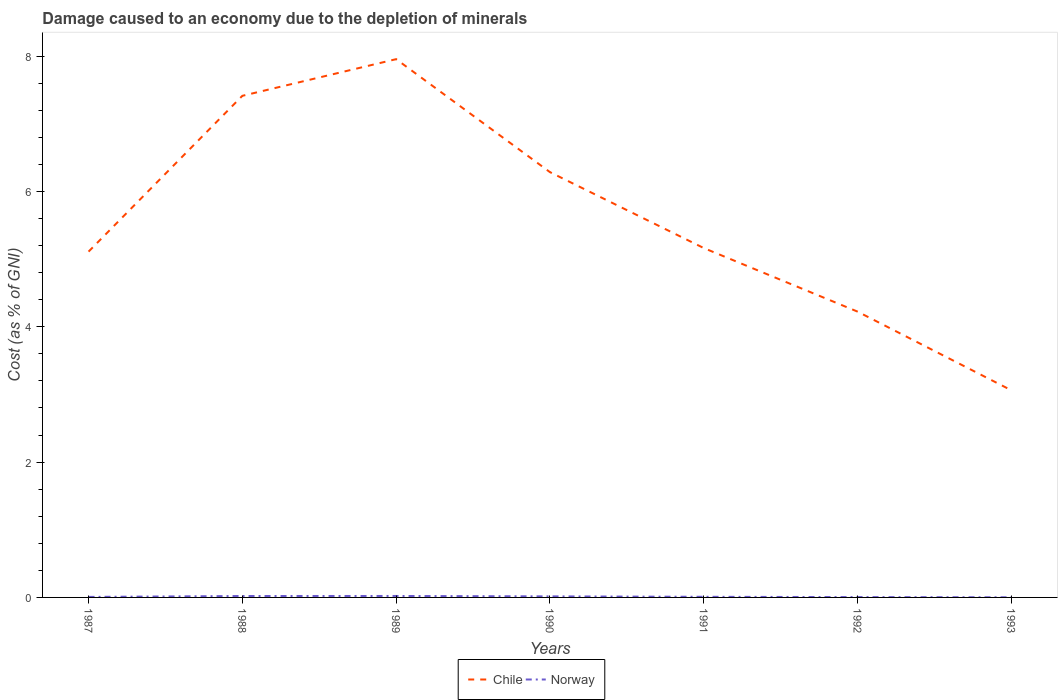Does the line corresponding to Norway intersect with the line corresponding to Chile?
Your answer should be very brief. No. Is the number of lines equal to the number of legend labels?
Your response must be concise. Yes. Across all years, what is the maximum cost of damage caused due to the depletion of minerals in Chile?
Give a very brief answer. 3.06. In which year was the cost of damage caused due to the depletion of minerals in Chile maximum?
Provide a short and direct response. 1993. What is the total cost of damage caused due to the depletion of minerals in Norway in the graph?
Provide a succinct answer. 0.01. What is the difference between the highest and the second highest cost of damage caused due to the depletion of minerals in Norway?
Provide a short and direct response. 0.02. Is the cost of damage caused due to the depletion of minerals in Chile strictly greater than the cost of damage caused due to the depletion of minerals in Norway over the years?
Provide a short and direct response. No. How many lines are there?
Provide a short and direct response. 2. Are the values on the major ticks of Y-axis written in scientific E-notation?
Your answer should be very brief. No. Does the graph contain any zero values?
Offer a terse response. No. Does the graph contain grids?
Your answer should be very brief. No. What is the title of the graph?
Your answer should be compact. Damage caused to an economy due to the depletion of minerals. What is the label or title of the Y-axis?
Keep it short and to the point. Cost (as % of GNI). What is the Cost (as % of GNI) in Chile in 1987?
Offer a terse response. 5.11. What is the Cost (as % of GNI) in Norway in 1987?
Offer a very short reply. 0.01. What is the Cost (as % of GNI) of Chile in 1988?
Your answer should be compact. 7.41. What is the Cost (as % of GNI) in Norway in 1988?
Ensure brevity in your answer.  0.02. What is the Cost (as % of GNI) in Chile in 1989?
Offer a terse response. 7.96. What is the Cost (as % of GNI) in Norway in 1989?
Provide a short and direct response. 0.02. What is the Cost (as % of GNI) of Chile in 1990?
Offer a terse response. 6.29. What is the Cost (as % of GNI) of Norway in 1990?
Provide a succinct answer. 0.02. What is the Cost (as % of GNI) of Chile in 1991?
Provide a succinct answer. 5.16. What is the Cost (as % of GNI) of Norway in 1991?
Provide a succinct answer. 0.01. What is the Cost (as % of GNI) of Chile in 1992?
Provide a short and direct response. 4.22. What is the Cost (as % of GNI) of Norway in 1992?
Make the answer very short. 0.01. What is the Cost (as % of GNI) in Chile in 1993?
Provide a succinct answer. 3.06. What is the Cost (as % of GNI) in Norway in 1993?
Ensure brevity in your answer.  0. Across all years, what is the maximum Cost (as % of GNI) of Chile?
Provide a short and direct response. 7.96. Across all years, what is the maximum Cost (as % of GNI) in Norway?
Offer a terse response. 0.02. Across all years, what is the minimum Cost (as % of GNI) in Chile?
Your answer should be very brief. 3.06. Across all years, what is the minimum Cost (as % of GNI) in Norway?
Provide a short and direct response. 0. What is the total Cost (as % of GNI) of Chile in the graph?
Make the answer very short. 39.22. What is the total Cost (as % of GNI) of Norway in the graph?
Offer a terse response. 0.08. What is the difference between the Cost (as % of GNI) in Chile in 1987 and that in 1988?
Keep it short and to the point. -2.3. What is the difference between the Cost (as % of GNI) of Norway in 1987 and that in 1988?
Make the answer very short. -0.01. What is the difference between the Cost (as % of GNI) of Chile in 1987 and that in 1989?
Your response must be concise. -2.84. What is the difference between the Cost (as % of GNI) in Norway in 1987 and that in 1989?
Your answer should be compact. -0.01. What is the difference between the Cost (as % of GNI) of Chile in 1987 and that in 1990?
Provide a short and direct response. -1.17. What is the difference between the Cost (as % of GNI) of Norway in 1987 and that in 1990?
Give a very brief answer. -0.01. What is the difference between the Cost (as % of GNI) in Chile in 1987 and that in 1991?
Make the answer very short. -0.05. What is the difference between the Cost (as % of GNI) of Norway in 1987 and that in 1991?
Your answer should be very brief. -0. What is the difference between the Cost (as % of GNI) of Chile in 1987 and that in 1992?
Provide a short and direct response. 0.89. What is the difference between the Cost (as % of GNI) of Norway in 1987 and that in 1992?
Give a very brief answer. 0. What is the difference between the Cost (as % of GNI) of Chile in 1987 and that in 1993?
Your response must be concise. 2.05. What is the difference between the Cost (as % of GNI) of Norway in 1987 and that in 1993?
Offer a terse response. 0.01. What is the difference between the Cost (as % of GNI) of Chile in 1988 and that in 1989?
Provide a short and direct response. -0.54. What is the difference between the Cost (as % of GNI) of Norway in 1988 and that in 1989?
Offer a very short reply. -0. What is the difference between the Cost (as % of GNI) in Chile in 1988 and that in 1990?
Give a very brief answer. 1.13. What is the difference between the Cost (as % of GNI) of Norway in 1988 and that in 1990?
Make the answer very short. 0.01. What is the difference between the Cost (as % of GNI) in Chile in 1988 and that in 1991?
Give a very brief answer. 2.25. What is the difference between the Cost (as % of GNI) of Norway in 1988 and that in 1991?
Provide a short and direct response. 0.01. What is the difference between the Cost (as % of GNI) in Chile in 1988 and that in 1992?
Provide a succinct answer. 3.19. What is the difference between the Cost (as % of GNI) in Norway in 1988 and that in 1992?
Provide a short and direct response. 0.02. What is the difference between the Cost (as % of GNI) in Chile in 1988 and that in 1993?
Your answer should be compact. 4.35. What is the difference between the Cost (as % of GNI) of Norway in 1988 and that in 1993?
Offer a terse response. 0.02. What is the difference between the Cost (as % of GNI) in Chile in 1989 and that in 1990?
Offer a very short reply. 1.67. What is the difference between the Cost (as % of GNI) of Norway in 1989 and that in 1990?
Offer a terse response. 0.01. What is the difference between the Cost (as % of GNI) of Chile in 1989 and that in 1991?
Make the answer very short. 2.79. What is the difference between the Cost (as % of GNI) of Norway in 1989 and that in 1991?
Your response must be concise. 0.01. What is the difference between the Cost (as % of GNI) of Chile in 1989 and that in 1992?
Your answer should be compact. 3.73. What is the difference between the Cost (as % of GNI) in Norway in 1989 and that in 1992?
Your response must be concise. 0.02. What is the difference between the Cost (as % of GNI) of Chile in 1989 and that in 1993?
Keep it short and to the point. 4.89. What is the difference between the Cost (as % of GNI) of Norway in 1989 and that in 1993?
Ensure brevity in your answer.  0.02. What is the difference between the Cost (as % of GNI) of Chile in 1990 and that in 1991?
Offer a terse response. 1.12. What is the difference between the Cost (as % of GNI) in Norway in 1990 and that in 1991?
Provide a succinct answer. 0.01. What is the difference between the Cost (as % of GNI) in Chile in 1990 and that in 1992?
Offer a very short reply. 2.06. What is the difference between the Cost (as % of GNI) of Norway in 1990 and that in 1992?
Give a very brief answer. 0.01. What is the difference between the Cost (as % of GNI) in Chile in 1990 and that in 1993?
Your response must be concise. 3.22. What is the difference between the Cost (as % of GNI) of Norway in 1990 and that in 1993?
Give a very brief answer. 0.01. What is the difference between the Cost (as % of GNI) in Chile in 1991 and that in 1992?
Provide a short and direct response. 0.94. What is the difference between the Cost (as % of GNI) in Norway in 1991 and that in 1992?
Keep it short and to the point. 0. What is the difference between the Cost (as % of GNI) in Chile in 1991 and that in 1993?
Your response must be concise. 2.1. What is the difference between the Cost (as % of GNI) in Norway in 1991 and that in 1993?
Your answer should be very brief. 0.01. What is the difference between the Cost (as % of GNI) of Chile in 1992 and that in 1993?
Ensure brevity in your answer.  1.16. What is the difference between the Cost (as % of GNI) in Norway in 1992 and that in 1993?
Ensure brevity in your answer.  0. What is the difference between the Cost (as % of GNI) of Chile in 1987 and the Cost (as % of GNI) of Norway in 1988?
Your answer should be compact. 5.09. What is the difference between the Cost (as % of GNI) of Chile in 1987 and the Cost (as % of GNI) of Norway in 1989?
Make the answer very short. 5.09. What is the difference between the Cost (as % of GNI) of Chile in 1987 and the Cost (as % of GNI) of Norway in 1990?
Your answer should be very brief. 5.1. What is the difference between the Cost (as % of GNI) of Chile in 1987 and the Cost (as % of GNI) of Norway in 1991?
Your response must be concise. 5.1. What is the difference between the Cost (as % of GNI) of Chile in 1987 and the Cost (as % of GNI) of Norway in 1992?
Offer a very short reply. 5.11. What is the difference between the Cost (as % of GNI) of Chile in 1987 and the Cost (as % of GNI) of Norway in 1993?
Offer a terse response. 5.11. What is the difference between the Cost (as % of GNI) in Chile in 1988 and the Cost (as % of GNI) in Norway in 1989?
Your response must be concise. 7.39. What is the difference between the Cost (as % of GNI) in Chile in 1988 and the Cost (as % of GNI) in Norway in 1990?
Offer a terse response. 7.4. What is the difference between the Cost (as % of GNI) in Chile in 1988 and the Cost (as % of GNI) in Norway in 1991?
Give a very brief answer. 7.41. What is the difference between the Cost (as % of GNI) of Chile in 1988 and the Cost (as % of GNI) of Norway in 1992?
Your answer should be compact. 7.41. What is the difference between the Cost (as % of GNI) in Chile in 1988 and the Cost (as % of GNI) in Norway in 1993?
Ensure brevity in your answer.  7.41. What is the difference between the Cost (as % of GNI) of Chile in 1989 and the Cost (as % of GNI) of Norway in 1990?
Give a very brief answer. 7.94. What is the difference between the Cost (as % of GNI) in Chile in 1989 and the Cost (as % of GNI) in Norway in 1991?
Keep it short and to the point. 7.95. What is the difference between the Cost (as % of GNI) in Chile in 1989 and the Cost (as % of GNI) in Norway in 1992?
Make the answer very short. 7.95. What is the difference between the Cost (as % of GNI) of Chile in 1989 and the Cost (as % of GNI) of Norway in 1993?
Provide a short and direct response. 7.95. What is the difference between the Cost (as % of GNI) of Chile in 1990 and the Cost (as % of GNI) of Norway in 1991?
Make the answer very short. 6.28. What is the difference between the Cost (as % of GNI) in Chile in 1990 and the Cost (as % of GNI) in Norway in 1992?
Your response must be concise. 6.28. What is the difference between the Cost (as % of GNI) in Chile in 1990 and the Cost (as % of GNI) in Norway in 1993?
Offer a terse response. 6.28. What is the difference between the Cost (as % of GNI) of Chile in 1991 and the Cost (as % of GNI) of Norway in 1992?
Provide a succinct answer. 5.16. What is the difference between the Cost (as % of GNI) in Chile in 1991 and the Cost (as % of GNI) in Norway in 1993?
Make the answer very short. 5.16. What is the difference between the Cost (as % of GNI) of Chile in 1992 and the Cost (as % of GNI) of Norway in 1993?
Your answer should be compact. 4.22. What is the average Cost (as % of GNI) in Chile per year?
Offer a very short reply. 5.6. What is the average Cost (as % of GNI) in Norway per year?
Give a very brief answer. 0.01. In the year 1987, what is the difference between the Cost (as % of GNI) in Chile and Cost (as % of GNI) in Norway?
Your response must be concise. 5.1. In the year 1988, what is the difference between the Cost (as % of GNI) in Chile and Cost (as % of GNI) in Norway?
Your answer should be very brief. 7.39. In the year 1989, what is the difference between the Cost (as % of GNI) in Chile and Cost (as % of GNI) in Norway?
Keep it short and to the point. 7.93. In the year 1990, what is the difference between the Cost (as % of GNI) of Chile and Cost (as % of GNI) of Norway?
Provide a succinct answer. 6.27. In the year 1991, what is the difference between the Cost (as % of GNI) in Chile and Cost (as % of GNI) in Norway?
Your answer should be very brief. 5.15. In the year 1992, what is the difference between the Cost (as % of GNI) of Chile and Cost (as % of GNI) of Norway?
Ensure brevity in your answer.  4.22. In the year 1993, what is the difference between the Cost (as % of GNI) in Chile and Cost (as % of GNI) in Norway?
Your answer should be compact. 3.06. What is the ratio of the Cost (as % of GNI) in Chile in 1987 to that in 1988?
Ensure brevity in your answer.  0.69. What is the ratio of the Cost (as % of GNI) of Norway in 1987 to that in 1988?
Offer a terse response. 0.36. What is the ratio of the Cost (as % of GNI) in Chile in 1987 to that in 1989?
Your response must be concise. 0.64. What is the ratio of the Cost (as % of GNI) of Norway in 1987 to that in 1989?
Make the answer very short. 0.35. What is the ratio of the Cost (as % of GNI) of Chile in 1987 to that in 1990?
Keep it short and to the point. 0.81. What is the ratio of the Cost (as % of GNI) in Norway in 1987 to that in 1990?
Provide a succinct answer. 0.49. What is the ratio of the Cost (as % of GNI) in Chile in 1987 to that in 1991?
Ensure brevity in your answer.  0.99. What is the ratio of the Cost (as % of GNI) in Norway in 1987 to that in 1991?
Give a very brief answer. 0.82. What is the ratio of the Cost (as % of GNI) in Chile in 1987 to that in 1992?
Give a very brief answer. 1.21. What is the ratio of the Cost (as % of GNI) of Norway in 1987 to that in 1992?
Your answer should be very brief. 1.49. What is the ratio of the Cost (as % of GNI) of Chile in 1987 to that in 1993?
Keep it short and to the point. 1.67. What is the ratio of the Cost (as % of GNI) in Norway in 1987 to that in 1993?
Provide a short and direct response. 3.61. What is the ratio of the Cost (as % of GNI) in Chile in 1988 to that in 1989?
Provide a short and direct response. 0.93. What is the ratio of the Cost (as % of GNI) of Norway in 1988 to that in 1989?
Offer a very short reply. 0.98. What is the ratio of the Cost (as % of GNI) of Chile in 1988 to that in 1990?
Your answer should be compact. 1.18. What is the ratio of the Cost (as % of GNI) of Norway in 1988 to that in 1990?
Make the answer very short. 1.35. What is the ratio of the Cost (as % of GNI) of Chile in 1988 to that in 1991?
Provide a short and direct response. 1.44. What is the ratio of the Cost (as % of GNI) of Norway in 1988 to that in 1991?
Your answer should be very brief. 2.29. What is the ratio of the Cost (as % of GNI) of Chile in 1988 to that in 1992?
Make the answer very short. 1.76. What is the ratio of the Cost (as % of GNI) of Norway in 1988 to that in 1992?
Ensure brevity in your answer.  4.13. What is the ratio of the Cost (as % of GNI) in Chile in 1988 to that in 1993?
Keep it short and to the point. 2.42. What is the ratio of the Cost (as % of GNI) of Norway in 1988 to that in 1993?
Offer a terse response. 10.04. What is the ratio of the Cost (as % of GNI) in Chile in 1989 to that in 1990?
Offer a terse response. 1.27. What is the ratio of the Cost (as % of GNI) of Norway in 1989 to that in 1990?
Your response must be concise. 1.38. What is the ratio of the Cost (as % of GNI) in Chile in 1989 to that in 1991?
Provide a short and direct response. 1.54. What is the ratio of the Cost (as % of GNI) in Norway in 1989 to that in 1991?
Your response must be concise. 2.33. What is the ratio of the Cost (as % of GNI) in Chile in 1989 to that in 1992?
Provide a succinct answer. 1.88. What is the ratio of the Cost (as % of GNI) of Norway in 1989 to that in 1992?
Offer a terse response. 4.21. What is the ratio of the Cost (as % of GNI) of Chile in 1989 to that in 1993?
Ensure brevity in your answer.  2.6. What is the ratio of the Cost (as % of GNI) in Norway in 1989 to that in 1993?
Ensure brevity in your answer.  10.23. What is the ratio of the Cost (as % of GNI) in Chile in 1990 to that in 1991?
Provide a succinct answer. 1.22. What is the ratio of the Cost (as % of GNI) of Norway in 1990 to that in 1991?
Offer a very short reply. 1.69. What is the ratio of the Cost (as % of GNI) in Chile in 1990 to that in 1992?
Make the answer very short. 1.49. What is the ratio of the Cost (as % of GNI) of Norway in 1990 to that in 1992?
Ensure brevity in your answer.  3.05. What is the ratio of the Cost (as % of GNI) of Chile in 1990 to that in 1993?
Your response must be concise. 2.05. What is the ratio of the Cost (as % of GNI) in Norway in 1990 to that in 1993?
Give a very brief answer. 7.41. What is the ratio of the Cost (as % of GNI) in Chile in 1991 to that in 1992?
Make the answer very short. 1.22. What is the ratio of the Cost (as % of GNI) of Norway in 1991 to that in 1992?
Offer a very short reply. 1.8. What is the ratio of the Cost (as % of GNI) in Chile in 1991 to that in 1993?
Provide a short and direct response. 1.69. What is the ratio of the Cost (as % of GNI) in Norway in 1991 to that in 1993?
Offer a terse response. 4.38. What is the ratio of the Cost (as % of GNI) of Chile in 1992 to that in 1993?
Make the answer very short. 1.38. What is the ratio of the Cost (as % of GNI) of Norway in 1992 to that in 1993?
Keep it short and to the point. 2.43. What is the difference between the highest and the second highest Cost (as % of GNI) in Chile?
Give a very brief answer. 0.54. What is the difference between the highest and the second highest Cost (as % of GNI) in Norway?
Offer a terse response. 0. What is the difference between the highest and the lowest Cost (as % of GNI) of Chile?
Make the answer very short. 4.89. What is the difference between the highest and the lowest Cost (as % of GNI) in Norway?
Offer a very short reply. 0.02. 